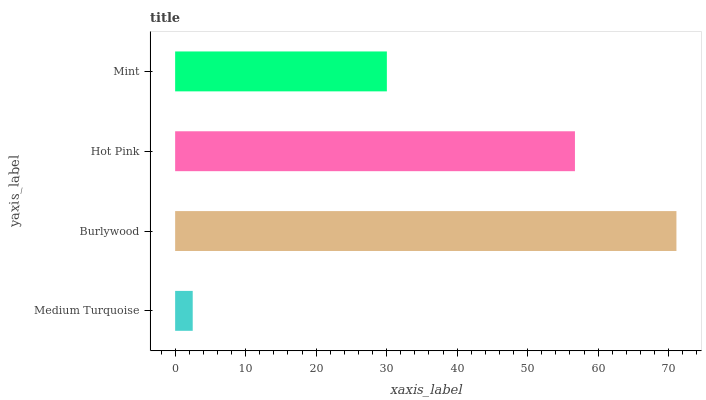Is Medium Turquoise the minimum?
Answer yes or no. Yes. Is Burlywood the maximum?
Answer yes or no. Yes. Is Hot Pink the minimum?
Answer yes or no. No. Is Hot Pink the maximum?
Answer yes or no. No. Is Burlywood greater than Hot Pink?
Answer yes or no. Yes. Is Hot Pink less than Burlywood?
Answer yes or no. Yes. Is Hot Pink greater than Burlywood?
Answer yes or no. No. Is Burlywood less than Hot Pink?
Answer yes or no. No. Is Hot Pink the high median?
Answer yes or no. Yes. Is Mint the low median?
Answer yes or no. Yes. Is Medium Turquoise the high median?
Answer yes or no. No. Is Hot Pink the low median?
Answer yes or no. No. 